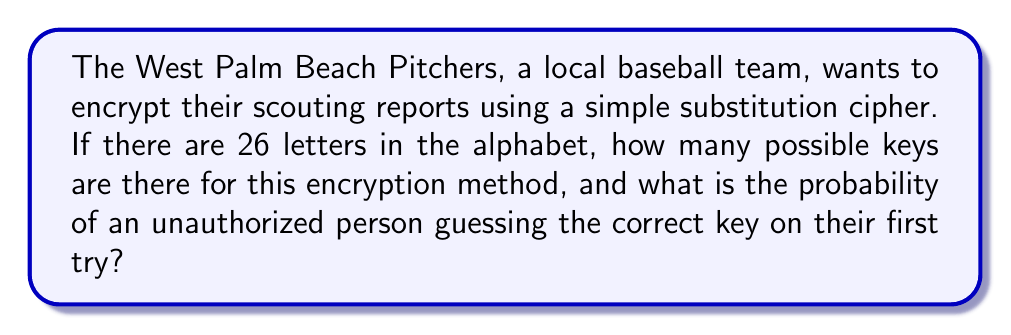Give your solution to this math problem. Let's approach this step-by-step:

1) In a simple substitution cipher, each letter of the alphabet is replaced by another letter. The key is the mapping of each letter to its substitute.

2) For the first letter, we have 26 choices.
3) For the second letter, we have 25 choices (as one letter has already been used).
4) For the third letter, we have 24 choices, and so on.

5) This scenario follows the multiplication principle. The total number of possible keys is:

   $$26 \times 25 \times 24 \times ... \times 2 \times 1$$

6) This is equivalent to 26 factorial, denoted as 26!

7) We can calculate this:
   $$26! = 403,291,461,126,605,635,584,000,000$$

8) To find the probability of guessing the correct key on the first try, we use the formula:

   $$P(\text{correct guess}) = \frac{1}{\text{number of possible keys}}$$

9) Substituting our value:

   $$P(\text{correct guess}) = \frac{1}{403,291,461,126,605,635,584,000,000}$$

   $$= 2.48 \times 10^{-27}$$

This probability is extremely small, indicating that guessing the key would be virtually impossible.
Answer: 26! keys; $2.48 \times 10^{-27}$ probability 